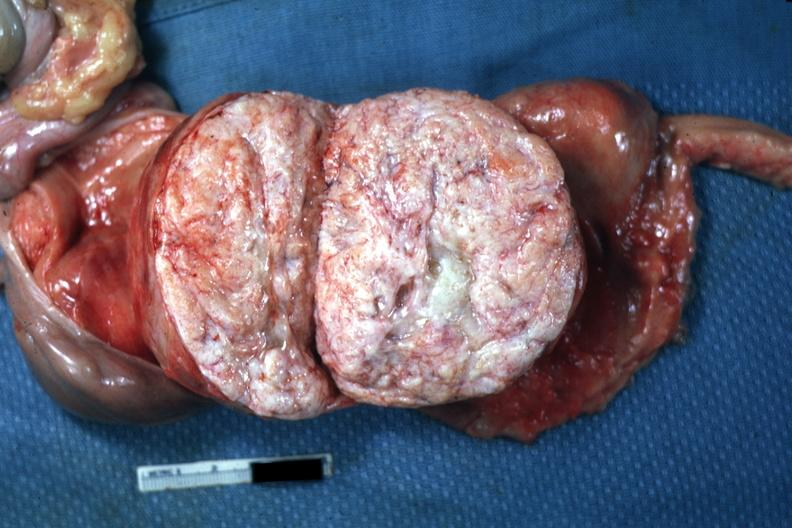s case of peritonitis slide quite typical close-up photo?
Answer the question using a single word or phrase. No 